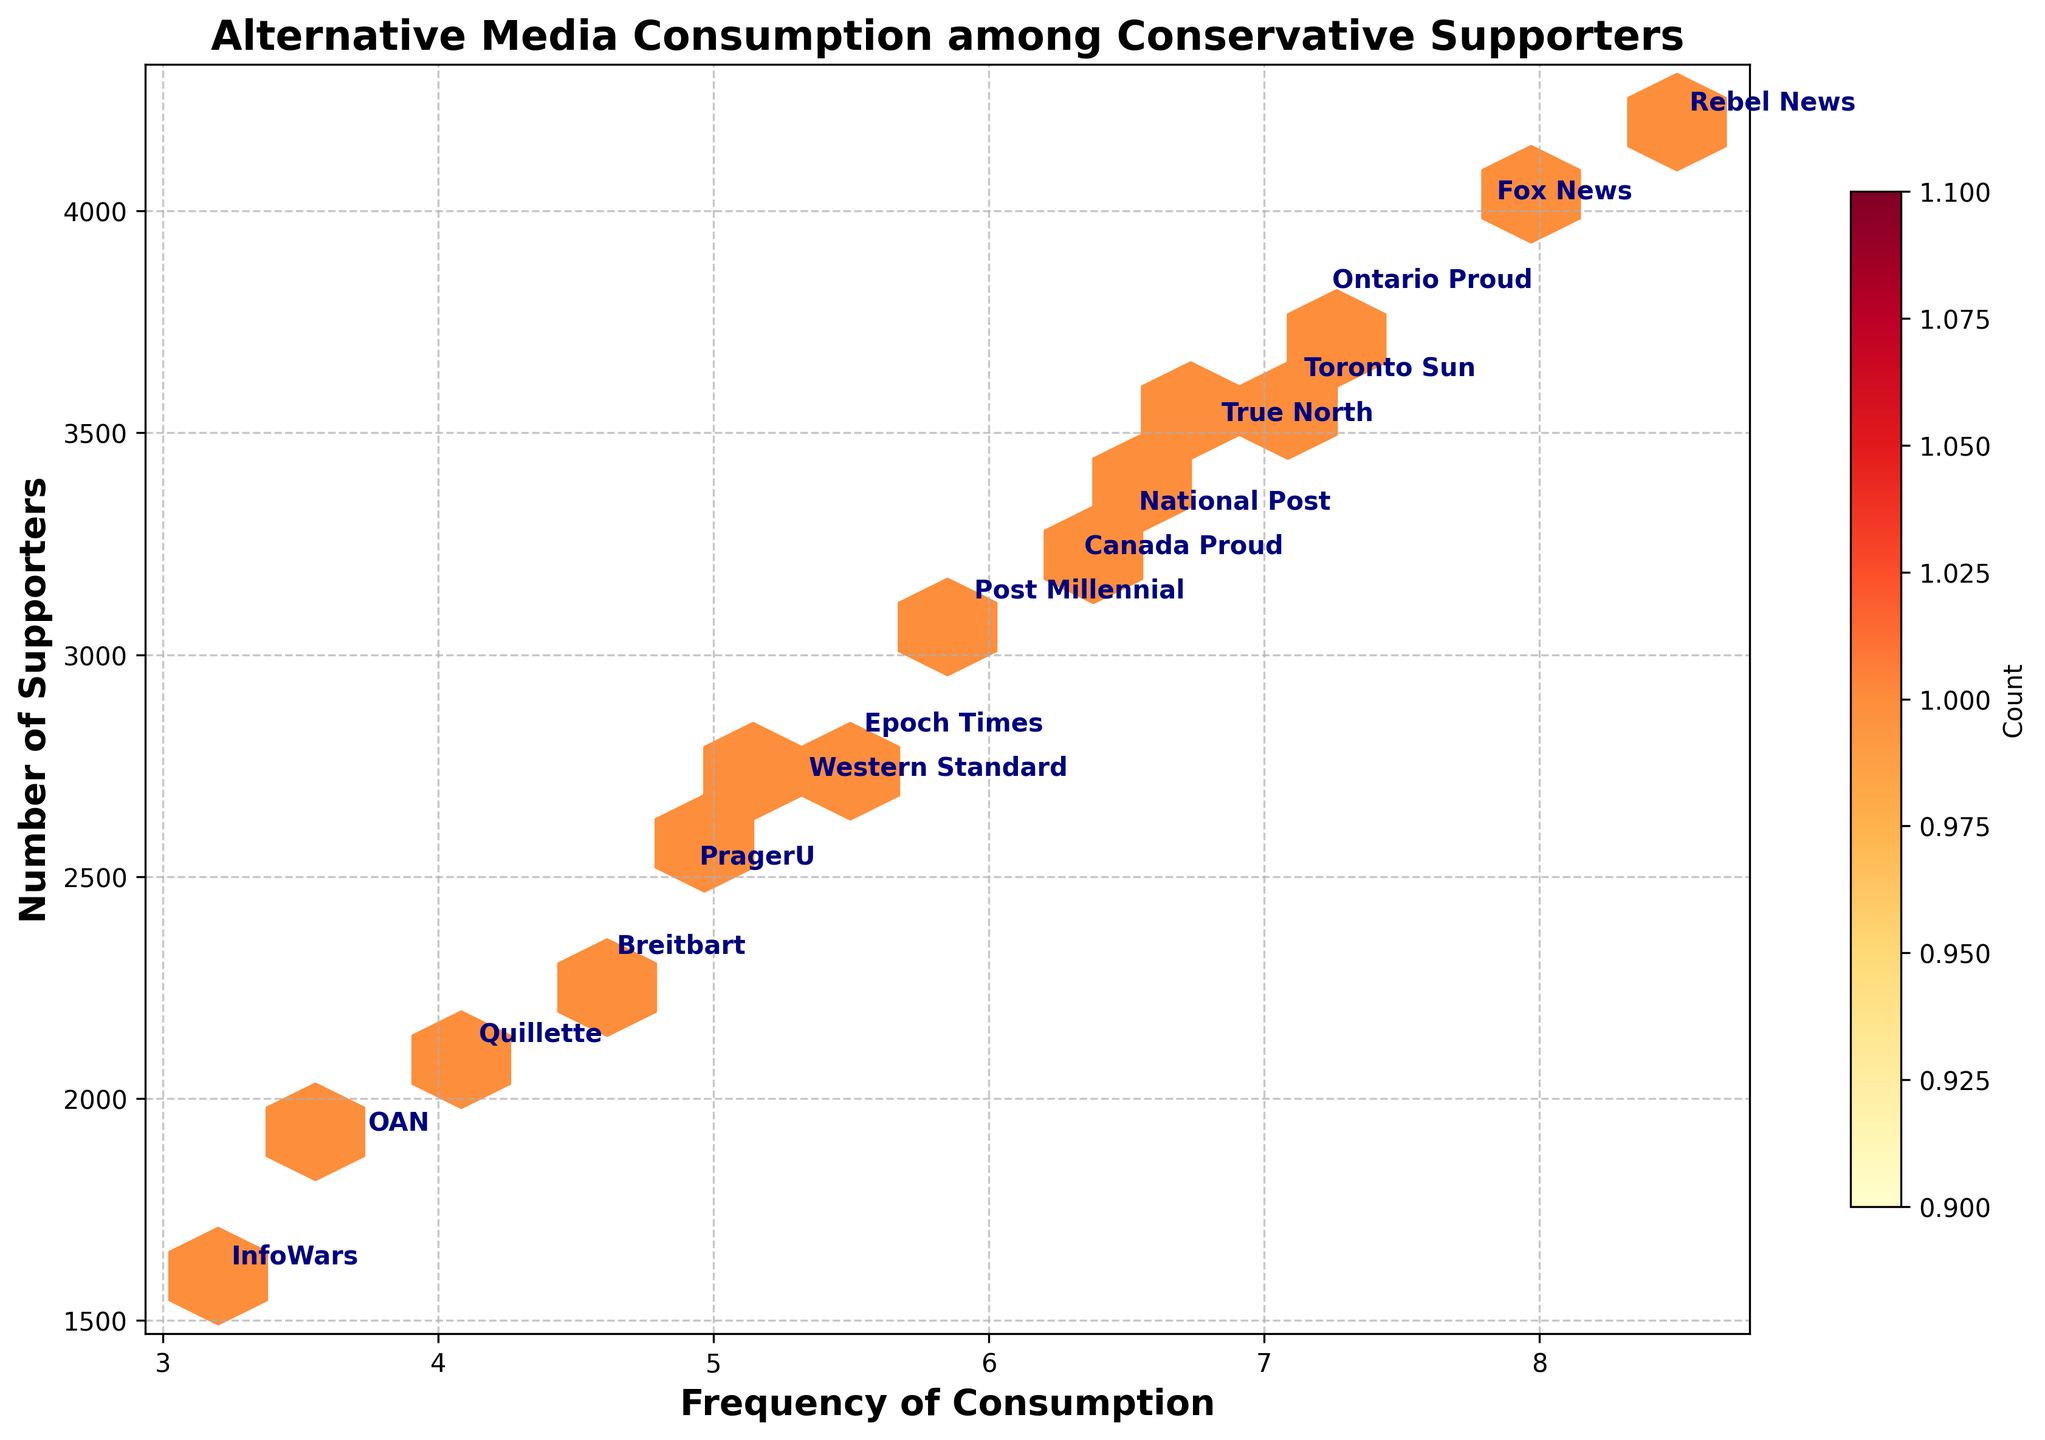What is the title of the figure? The title is generally positioned at the top of the figure and should be clear and readable. "Alternative Media Consumption among Conservative Supporters" is displayed prominently.
Answer: Alternative Media Consumption among Conservative Supporters What are the labels for the x-axis and y-axis? The x-axis label describes what the horizontal axis represents, and the y-axis label describes the vertical axis. The x-axis represents "Frequency of Consumption" and the y-axis represents "Number of Supporters."
Answer: Frequency of Consumption; Number of Supporters Which platform has the highest number of supporters? To find the platform with the highest number of supporters, look for the data point at the highest position on the y-axis. Rebel News has the highest number of supporters.
Answer: Rebel News Which platform is most frequently consumed? To identify the most frequently consumed platform, find the data point with the maximum value on the x-axis. Rebel News is the most frequently consumed.
Answer: Rebel News What is the total number of supporters for Ontario Proud and True North? Add the number of supporters for Ontario Proud and True North. Ontario Proud has 3800 supporters and True North has 3500 supporters. So, 3800 + 3500 = 7300.
Answer: 7300 Which platform has a lower frequency of consumption, InfoWars or OAN? Compare the x-axis values (Frequency of Consumption) for InfoWars and OAN. InfoWars has a frequency of 3.2 and OAN has a frequency of 3.7. Thus, InfoWars has a lower frequency of consumption.
Answer: InfoWars What is the approximate range of the frequency of consumption among all the platforms? To find the range, subtract the minimum frequency from the maximum frequency. The minimum frequency is 3.2 (InfoWars) and the maximum is 8.5 (Rebel News), so the range is 8.5 - 3.2 = 5.3.
Answer: 5.3 Which platform, Fox News or Breitbart, has more conservative supporters? Compare the y-axis values (Number of Supporters) for Fox News and Breitbart. Fox News has 4000 supporters and Breitbart has 2300 supporters. Therefore, Fox News has more conservative supporters.
Answer: Fox News Between PragerU and OAN, which one has higher consumption frequency and how much higher? Compare the x-axis values for PragerU and OAN. PragerU has a frequency of 4.9 and OAN has a frequency of 3.7. The difference is 4.9 - 3.7 = 1.2. So, PragerU has a higher consumption frequency by 1.2.
Answer: PragerU, 1.2 What color indicates the highest count in the hexbin plot? The color map 'YlOrRd' ranges from light yellow to dark red, where the darkest red typically indicates the highest count. Look for the darkest red cells.
Answer: Dark red 